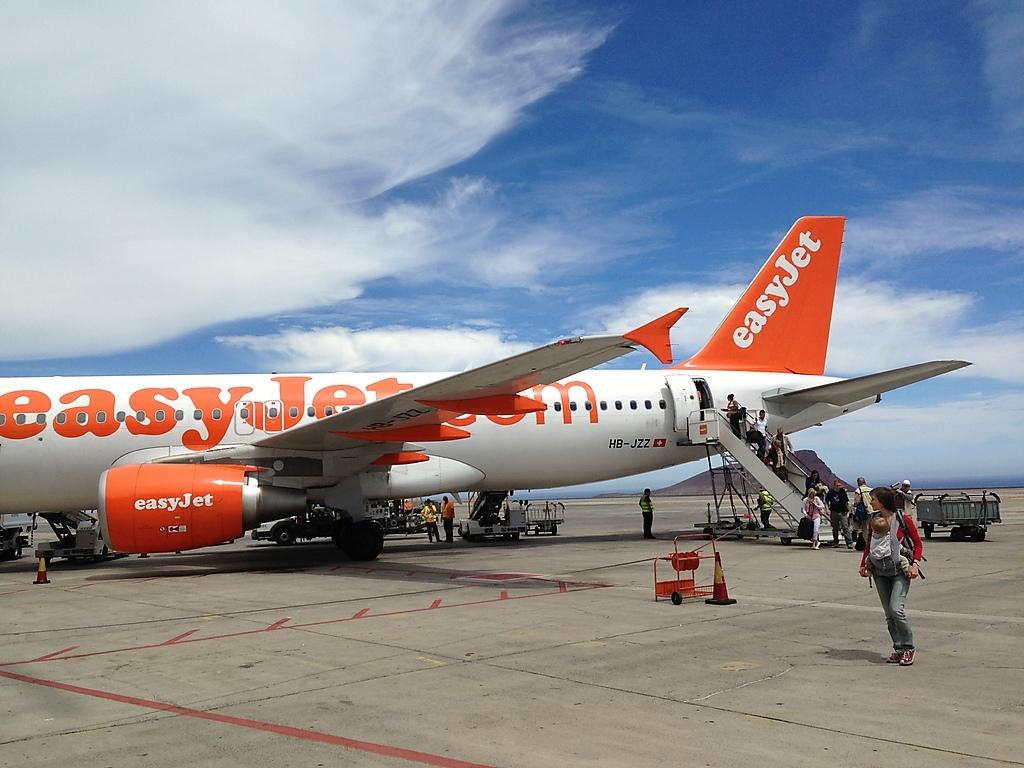<image>
Share a concise interpretation of the image provided. Rear half of the easy jet plane is showing with people getting off the plane. 